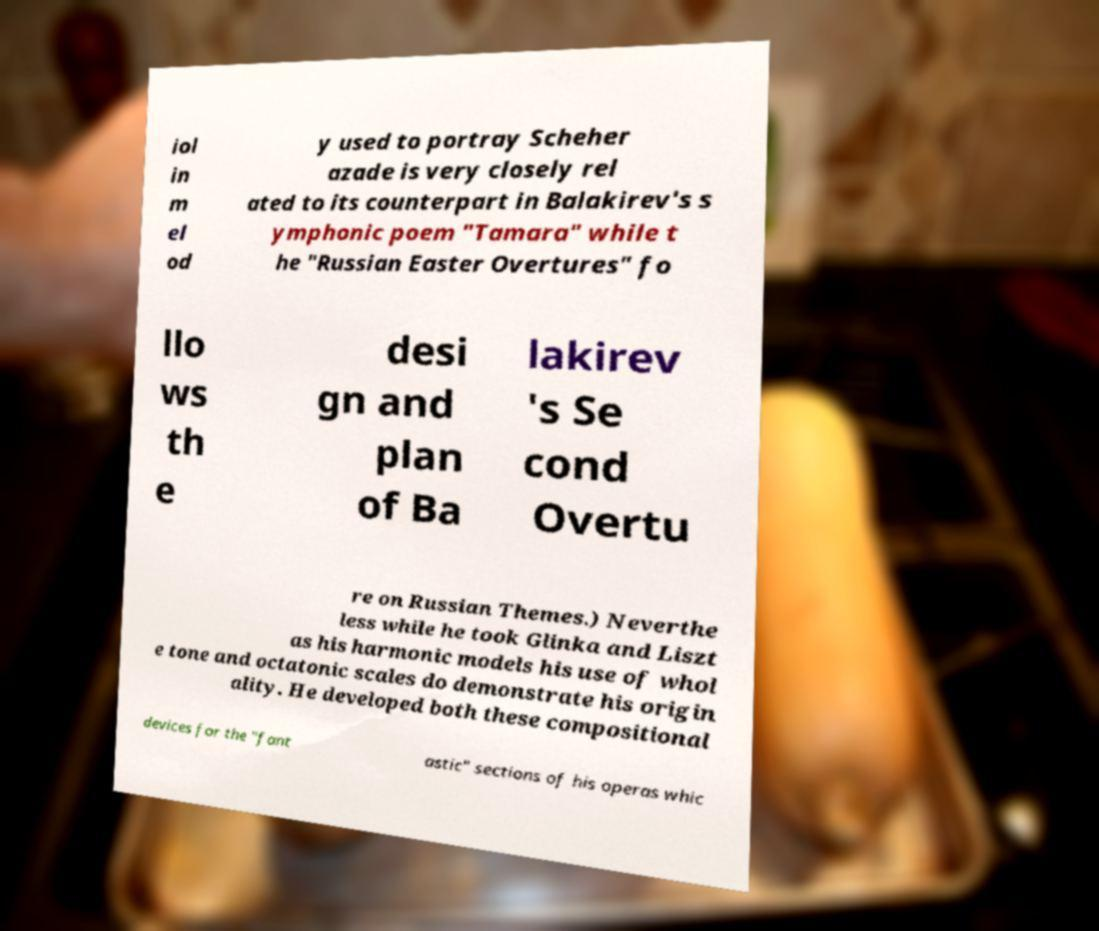Can you read and provide the text displayed in the image?This photo seems to have some interesting text. Can you extract and type it out for me? iol in m el od y used to portray Scheher azade is very closely rel ated to its counterpart in Balakirev's s ymphonic poem "Tamara" while t he "Russian Easter Overtures" fo llo ws th e desi gn and plan of Ba lakirev 's Se cond Overtu re on Russian Themes.) Neverthe less while he took Glinka and Liszt as his harmonic models his use of whol e tone and octatonic scales do demonstrate his origin ality. He developed both these compositional devices for the "fant astic" sections of his operas whic 